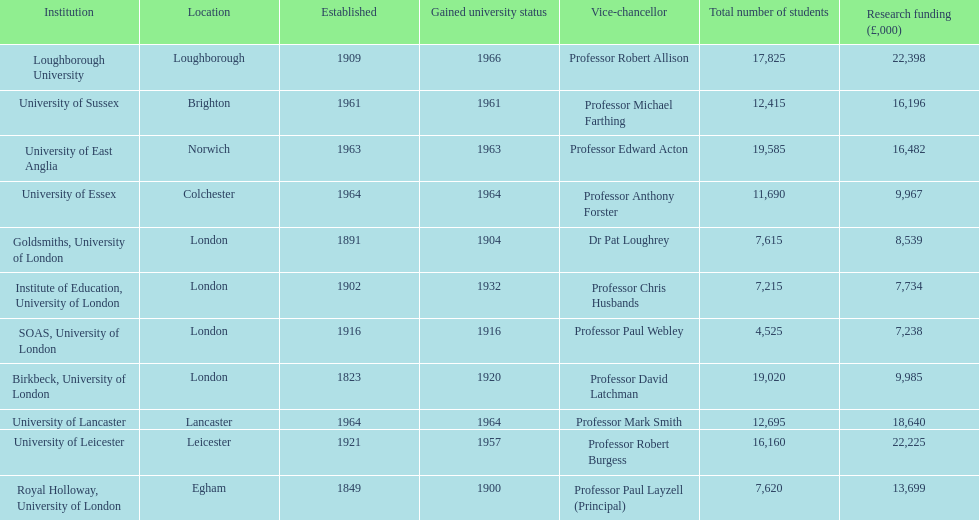Where is birbeck,university of london located? London. Which university was established in 1921? University of Leicester. Which institution gained university status recently? Loughborough University. 